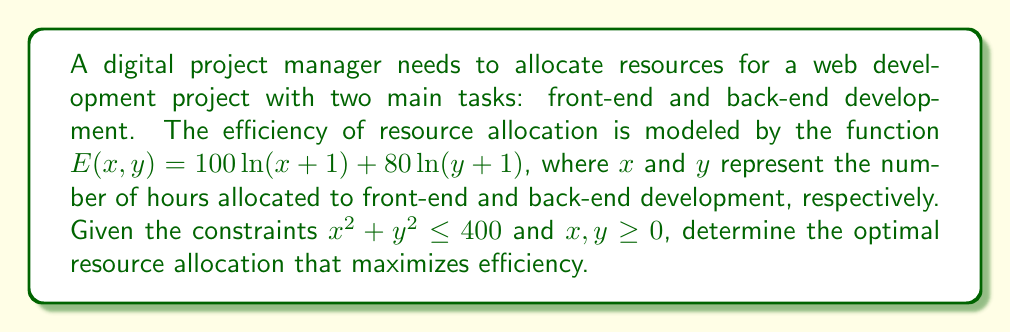Can you answer this question? To solve this problem, we'll use the method of Lagrange multipliers:

1) Define the Lagrangian function:
   $$L(x,y,\lambda) = 100\ln(x+1) + 80\ln(y+1) - \lambda(x^2 + y^2 - 400)$$

2) Calculate partial derivatives and set them to zero:
   $$\frac{\partial L}{\partial x} = \frac{100}{x+1} - 2\lambda x = 0$$
   $$\frac{\partial L}{\partial y} = \frac{80}{y+1} - 2\lambda y = 0$$
   $$\frac{\partial L}{\partial \lambda} = x^2 + y^2 - 400 = 0$$

3) From the first two equations:
   $$\frac{100}{x+1} = 2\lambda x \quad \text{and} \quad \frac{80}{y+1} = 2\lambda y$$

4) Divide these equations:
   $$\frac{100}{80} \cdot \frac{y+1}{x+1} = \frac{x}{y}$$
   $$\frac{5}{4} \cdot \frac{y+1}{x+1} = \frac{x}{y}$$

5) Cross-multiply:
   $$5y(y+1) = 4x(x+1)$$

6) Expand:
   $$5y^2 + 5y = 4x^2 + 4x$$

7) Substitute $y^2 = 400 - x^2$ from the constraint:
   $$5(400 - x^2) + 5y = 4x^2 + 4x$$
   $$2000 - 5x^2 + 5y = 4x^2 + 4x$$

8) Solve for y:
   $$y = \frac{4x^2 + 4x - 2000 + 5x^2}{5} = \frac{9x^2 + 4x - 2000}{5}$$

9) Substitute this back into the constraint:
   $$x^2 + (\frac{9x^2 + 4x - 2000}{5})^2 = 400$$

10) Solve this equation numerically to get $x \approx 14.14$

11) Calculate y:
    $$y = \frac{9(14.14)^2 + 4(14.14) - 2000}{5} \approx 14.14$$

Therefore, the optimal allocation is approximately 14.14 hours for both front-end and back-end development.
Answer: $(14.14, 14.14)$ 